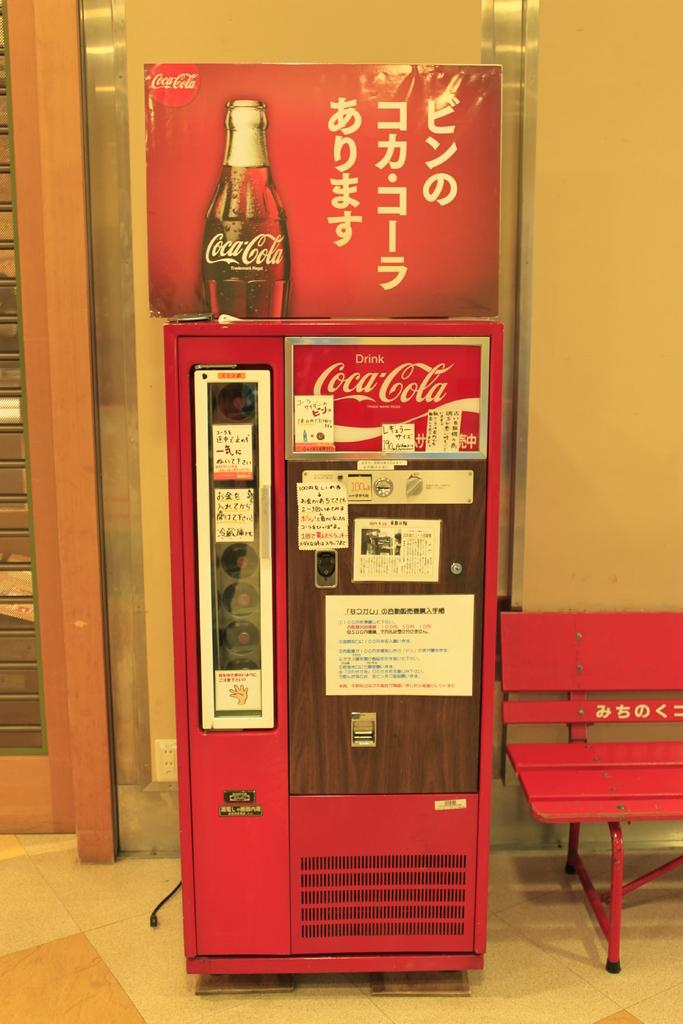What is the color of the machine in the image? The machine in the image is red. What brand is associated with the board in the image? The board in the image is a Coca Cola board. What type of seating is present in the image? There is a bench in the image. What type of structure is visible in the image? There is a wall in the image. What type of entrance is present in the image? There is a door in the image. What surface is the machine, bench, and Coca Cola board placed on? There is a floor in the image. What type of cart is being used to transport the ship in the image? There is no cart or ship present in the image; it only features a red machine, a Coca Cola board, a bench, a wall, a door, and a floor. 